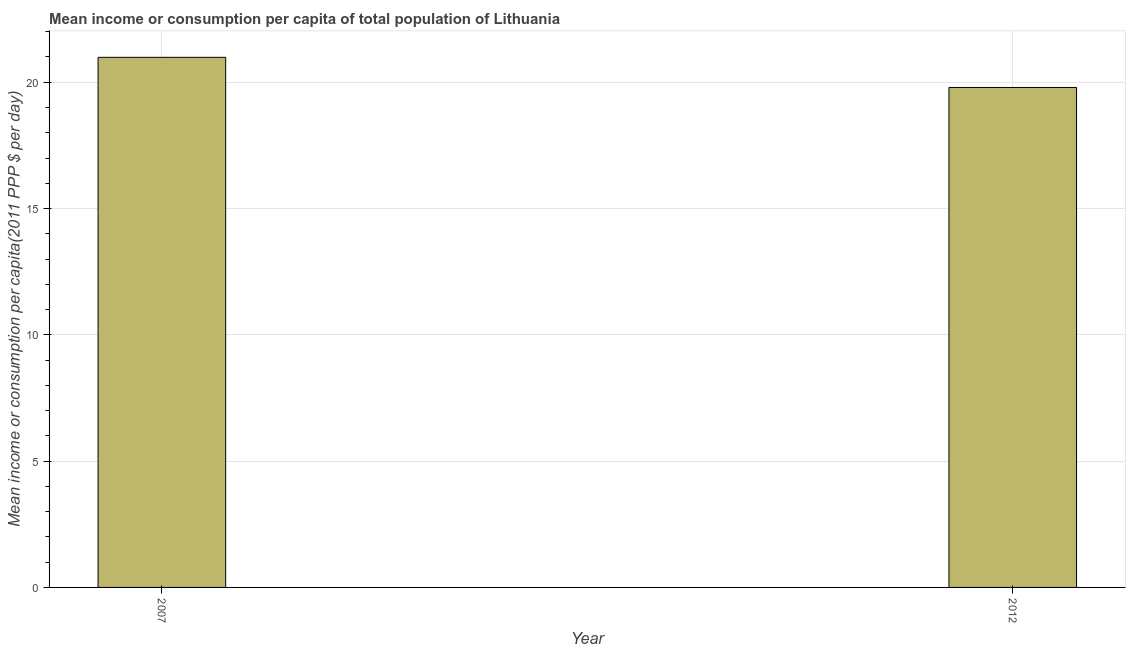Does the graph contain grids?
Provide a succinct answer. Yes. What is the title of the graph?
Provide a short and direct response. Mean income or consumption per capita of total population of Lithuania. What is the label or title of the Y-axis?
Your response must be concise. Mean income or consumption per capita(2011 PPP $ per day). What is the mean income or consumption in 2012?
Your answer should be compact. 19.79. Across all years, what is the maximum mean income or consumption?
Make the answer very short. 20.99. Across all years, what is the minimum mean income or consumption?
Your response must be concise. 19.79. In which year was the mean income or consumption minimum?
Provide a short and direct response. 2012. What is the sum of the mean income or consumption?
Provide a short and direct response. 40.78. What is the difference between the mean income or consumption in 2007 and 2012?
Make the answer very short. 1.19. What is the average mean income or consumption per year?
Keep it short and to the point. 20.39. What is the median mean income or consumption?
Provide a succinct answer. 20.39. In how many years, is the mean income or consumption greater than 4 $?
Make the answer very short. 2. What is the ratio of the mean income or consumption in 2007 to that in 2012?
Offer a terse response. 1.06. Is the mean income or consumption in 2007 less than that in 2012?
Give a very brief answer. No. In how many years, is the mean income or consumption greater than the average mean income or consumption taken over all years?
Give a very brief answer. 1. How many bars are there?
Provide a short and direct response. 2. How many years are there in the graph?
Ensure brevity in your answer.  2. What is the Mean income or consumption per capita(2011 PPP $ per day) of 2007?
Your answer should be very brief. 20.99. What is the Mean income or consumption per capita(2011 PPP $ per day) of 2012?
Your response must be concise. 19.79. What is the difference between the Mean income or consumption per capita(2011 PPP $ per day) in 2007 and 2012?
Ensure brevity in your answer.  1.19. What is the ratio of the Mean income or consumption per capita(2011 PPP $ per day) in 2007 to that in 2012?
Offer a terse response. 1.06. 